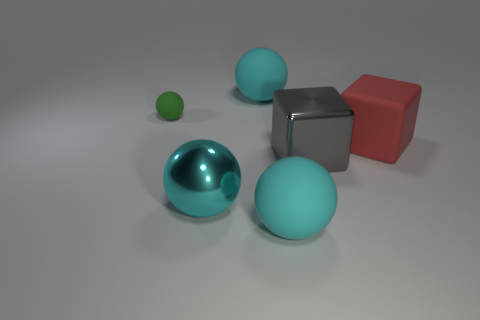Add 4 gray shiny cubes. How many objects exist? 10 Subtract all big cyan shiny balls. How many balls are left? 3 Subtract all spheres. How many objects are left? 2 Subtract 2 balls. How many balls are left? 2 Add 5 big red rubber cubes. How many big red rubber cubes exist? 6 Subtract all green spheres. How many spheres are left? 3 Subtract 0 brown cylinders. How many objects are left? 6 Subtract all green balls. Subtract all purple blocks. How many balls are left? 3 Subtract all cyan cubes. How many cyan spheres are left? 3 Subtract all big matte cubes. Subtract all tiny spheres. How many objects are left? 4 